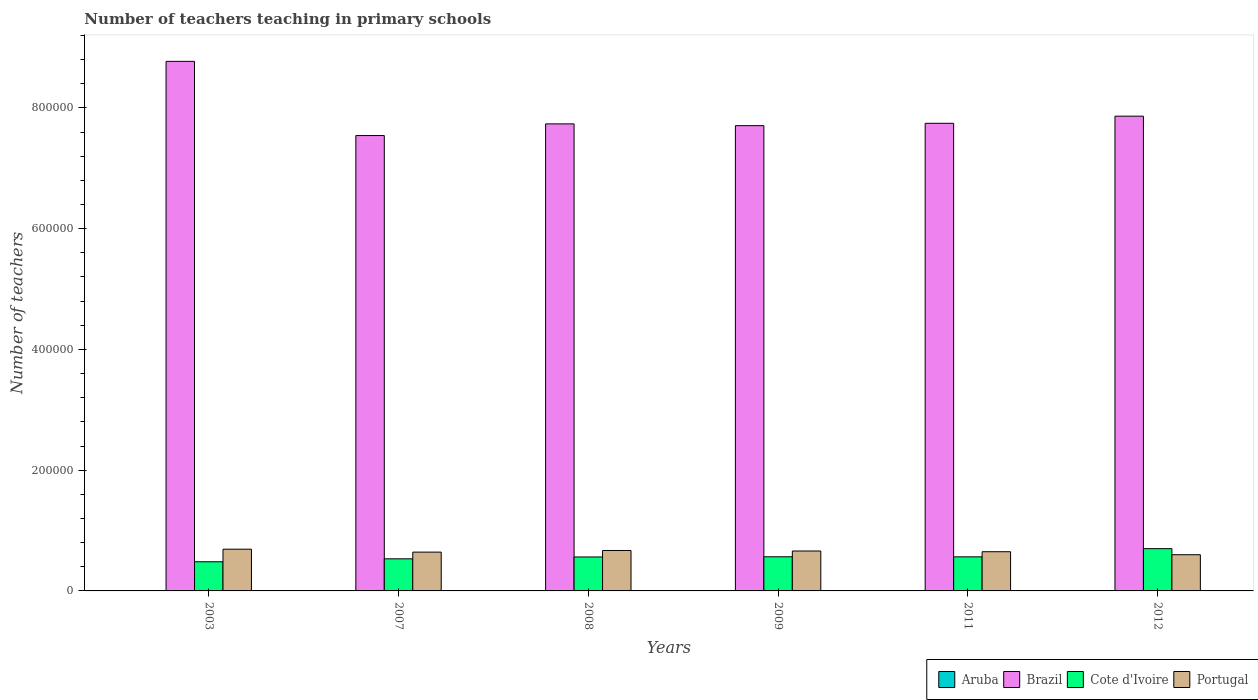How many different coloured bars are there?
Offer a very short reply. 4. How many groups of bars are there?
Your answer should be very brief. 6. Are the number of bars on each tick of the X-axis equal?
Give a very brief answer. Yes. How many bars are there on the 5th tick from the left?
Offer a very short reply. 4. How many bars are there on the 5th tick from the right?
Ensure brevity in your answer.  4. What is the label of the 1st group of bars from the left?
Ensure brevity in your answer.  2003. What is the number of teachers teaching in primary schools in Cote d'Ivoire in 2003?
Offer a terse response. 4.83e+04. Across all years, what is the maximum number of teachers teaching in primary schools in Portugal?
Your answer should be very brief. 6.91e+04. Across all years, what is the minimum number of teachers teaching in primary schools in Aruba?
Your response must be concise. 537. In which year was the number of teachers teaching in primary schools in Cote d'Ivoire maximum?
Your response must be concise. 2012. What is the total number of teachers teaching in primary schools in Aruba in the graph?
Provide a short and direct response. 3497. What is the difference between the number of teachers teaching in primary schools in Brazil in 2008 and that in 2012?
Provide a succinct answer. -1.28e+04. What is the difference between the number of teachers teaching in primary schools in Cote d'Ivoire in 2011 and the number of teachers teaching in primary schools in Aruba in 2009?
Ensure brevity in your answer.  5.59e+04. What is the average number of teachers teaching in primary schools in Aruba per year?
Provide a succinct answer. 582.83. In the year 2012, what is the difference between the number of teachers teaching in primary schools in Brazil and number of teachers teaching in primary schools in Portugal?
Ensure brevity in your answer.  7.26e+05. In how many years, is the number of teachers teaching in primary schools in Brazil greater than 520000?
Ensure brevity in your answer.  6. What is the ratio of the number of teachers teaching in primary schools in Brazil in 2003 to that in 2009?
Your answer should be compact. 1.14. What is the difference between the highest and the second highest number of teachers teaching in primary schools in Portugal?
Ensure brevity in your answer.  2153. What is the difference between the highest and the lowest number of teachers teaching in primary schools in Cote d'Ivoire?
Provide a succinct answer. 2.17e+04. In how many years, is the number of teachers teaching in primary schools in Brazil greater than the average number of teachers teaching in primary schools in Brazil taken over all years?
Provide a succinct answer. 1. What does the 3rd bar from the right in 2011 represents?
Your answer should be compact. Brazil. How many years are there in the graph?
Your response must be concise. 6. What is the difference between two consecutive major ticks on the Y-axis?
Make the answer very short. 2.00e+05. Are the values on the major ticks of Y-axis written in scientific E-notation?
Provide a succinct answer. No. Does the graph contain grids?
Offer a very short reply. No. What is the title of the graph?
Provide a short and direct response. Number of teachers teaching in primary schools. Does "Ukraine" appear as one of the legend labels in the graph?
Keep it short and to the point. No. What is the label or title of the Y-axis?
Your answer should be very brief. Number of teachers. What is the Number of teachers in Aruba in 2003?
Your response must be concise. 537. What is the Number of teachers in Brazil in 2003?
Ensure brevity in your answer.  8.77e+05. What is the Number of teachers in Cote d'Ivoire in 2003?
Ensure brevity in your answer.  4.83e+04. What is the Number of teachers of Portugal in 2003?
Your answer should be very brief. 6.91e+04. What is the Number of teachers in Aruba in 2007?
Your answer should be very brief. 594. What is the Number of teachers of Brazil in 2007?
Give a very brief answer. 7.54e+05. What is the Number of teachers in Cote d'Ivoire in 2007?
Provide a short and direct response. 5.32e+04. What is the Number of teachers in Portugal in 2007?
Your answer should be very brief. 6.43e+04. What is the Number of teachers of Aruba in 2008?
Give a very brief answer. 579. What is the Number of teachers in Brazil in 2008?
Ensure brevity in your answer.  7.74e+05. What is the Number of teachers of Cote d'Ivoire in 2008?
Offer a very short reply. 5.62e+04. What is the Number of teachers in Portugal in 2008?
Provide a short and direct response. 6.70e+04. What is the Number of teachers of Aruba in 2009?
Ensure brevity in your answer.  582. What is the Number of teachers of Brazil in 2009?
Offer a very short reply. 7.71e+05. What is the Number of teachers in Cote d'Ivoire in 2009?
Your answer should be compact. 5.66e+04. What is the Number of teachers of Portugal in 2009?
Offer a terse response. 6.61e+04. What is the Number of teachers in Aruba in 2011?
Make the answer very short. 604. What is the Number of teachers of Brazil in 2011?
Provide a succinct answer. 7.75e+05. What is the Number of teachers of Cote d'Ivoire in 2011?
Ensure brevity in your answer.  5.65e+04. What is the Number of teachers of Portugal in 2011?
Provide a succinct answer. 6.49e+04. What is the Number of teachers of Aruba in 2012?
Offer a very short reply. 601. What is the Number of teachers in Brazil in 2012?
Make the answer very short. 7.86e+05. What is the Number of teachers in Cote d'Ivoire in 2012?
Your answer should be compact. 7.00e+04. What is the Number of teachers of Portugal in 2012?
Offer a terse response. 6.00e+04. Across all years, what is the maximum Number of teachers in Aruba?
Make the answer very short. 604. Across all years, what is the maximum Number of teachers in Brazil?
Offer a terse response. 8.77e+05. Across all years, what is the maximum Number of teachers in Cote d'Ivoire?
Your response must be concise. 7.00e+04. Across all years, what is the maximum Number of teachers in Portugal?
Offer a very short reply. 6.91e+04. Across all years, what is the minimum Number of teachers in Aruba?
Give a very brief answer. 537. Across all years, what is the minimum Number of teachers in Brazil?
Provide a short and direct response. 7.54e+05. Across all years, what is the minimum Number of teachers in Cote d'Ivoire?
Offer a very short reply. 4.83e+04. Across all years, what is the minimum Number of teachers in Portugal?
Your answer should be very brief. 6.00e+04. What is the total Number of teachers in Aruba in the graph?
Give a very brief answer. 3497. What is the total Number of teachers in Brazil in the graph?
Your answer should be very brief. 4.74e+06. What is the total Number of teachers in Cote d'Ivoire in the graph?
Your answer should be very brief. 3.41e+05. What is the total Number of teachers of Portugal in the graph?
Provide a succinct answer. 3.91e+05. What is the difference between the Number of teachers of Aruba in 2003 and that in 2007?
Offer a very short reply. -57. What is the difference between the Number of teachers of Brazil in 2003 and that in 2007?
Give a very brief answer. 1.23e+05. What is the difference between the Number of teachers in Cote d'Ivoire in 2003 and that in 2007?
Make the answer very short. -4853. What is the difference between the Number of teachers of Portugal in 2003 and that in 2007?
Provide a succinct answer. 4835. What is the difference between the Number of teachers of Aruba in 2003 and that in 2008?
Ensure brevity in your answer.  -42. What is the difference between the Number of teachers of Brazil in 2003 and that in 2008?
Make the answer very short. 1.04e+05. What is the difference between the Number of teachers of Cote d'Ivoire in 2003 and that in 2008?
Give a very brief answer. -7940. What is the difference between the Number of teachers in Portugal in 2003 and that in 2008?
Make the answer very short. 2153. What is the difference between the Number of teachers of Aruba in 2003 and that in 2009?
Offer a very short reply. -45. What is the difference between the Number of teachers in Brazil in 2003 and that in 2009?
Your response must be concise. 1.07e+05. What is the difference between the Number of teachers in Cote d'Ivoire in 2003 and that in 2009?
Your answer should be compact. -8267. What is the difference between the Number of teachers of Portugal in 2003 and that in 2009?
Your response must be concise. 3003. What is the difference between the Number of teachers in Aruba in 2003 and that in 2011?
Your answer should be compact. -67. What is the difference between the Number of teachers in Brazil in 2003 and that in 2011?
Provide a succinct answer. 1.03e+05. What is the difference between the Number of teachers in Cote d'Ivoire in 2003 and that in 2011?
Make the answer very short. -8147. What is the difference between the Number of teachers in Portugal in 2003 and that in 2011?
Keep it short and to the point. 4180. What is the difference between the Number of teachers of Aruba in 2003 and that in 2012?
Provide a succinct answer. -64. What is the difference between the Number of teachers of Brazil in 2003 and that in 2012?
Provide a succinct answer. 9.08e+04. What is the difference between the Number of teachers in Cote d'Ivoire in 2003 and that in 2012?
Provide a succinct answer. -2.17e+04. What is the difference between the Number of teachers in Portugal in 2003 and that in 2012?
Your response must be concise. 9154. What is the difference between the Number of teachers of Aruba in 2007 and that in 2008?
Ensure brevity in your answer.  15. What is the difference between the Number of teachers in Brazil in 2007 and that in 2008?
Ensure brevity in your answer.  -1.93e+04. What is the difference between the Number of teachers in Cote d'Ivoire in 2007 and that in 2008?
Ensure brevity in your answer.  -3087. What is the difference between the Number of teachers in Portugal in 2007 and that in 2008?
Provide a succinct answer. -2682. What is the difference between the Number of teachers in Aruba in 2007 and that in 2009?
Your answer should be compact. 12. What is the difference between the Number of teachers of Brazil in 2007 and that in 2009?
Give a very brief answer. -1.64e+04. What is the difference between the Number of teachers in Cote d'Ivoire in 2007 and that in 2009?
Keep it short and to the point. -3414. What is the difference between the Number of teachers of Portugal in 2007 and that in 2009?
Offer a very short reply. -1832. What is the difference between the Number of teachers in Brazil in 2007 and that in 2011?
Provide a short and direct response. -2.03e+04. What is the difference between the Number of teachers in Cote d'Ivoire in 2007 and that in 2011?
Your answer should be very brief. -3294. What is the difference between the Number of teachers in Portugal in 2007 and that in 2011?
Offer a very short reply. -655. What is the difference between the Number of teachers in Brazil in 2007 and that in 2012?
Ensure brevity in your answer.  -3.21e+04. What is the difference between the Number of teachers of Cote d'Ivoire in 2007 and that in 2012?
Provide a short and direct response. -1.69e+04. What is the difference between the Number of teachers in Portugal in 2007 and that in 2012?
Your answer should be very brief. 4319. What is the difference between the Number of teachers of Brazil in 2008 and that in 2009?
Provide a succinct answer. 2921. What is the difference between the Number of teachers in Cote d'Ivoire in 2008 and that in 2009?
Ensure brevity in your answer.  -327. What is the difference between the Number of teachers of Portugal in 2008 and that in 2009?
Keep it short and to the point. 850. What is the difference between the Number of teachers in Brazil in 2008 and that in 2011?
Offer a terse response. -951. What is the difference between the Number of teachers of Cote d'Ivoire in 2008 and that in 2011?
Your response must be concise. -207. What is the difference between the Number of teachers in Portugal in 2008 and that in 2011?
Make the answer very short. 2027. What is the difference between the Number of teachers of Aruba in 2008 and that in 2012?
Your answer should be compact. -22. What is the difference between the Number of teachers in Brazil in 2008 and that in 2012?
Provide a succinct answer. -1.28e+04. What is the difference between the Number of teachers of Cote d'Ivoire in 2008 and that in 2012?
Your response must be concise. -1.38e+04. What is the difference between the Number of teachers of Portugal in 2008 and that in 2012?
Your answer should be very brief. 7001. What is the difference between the Number of teachers in Aruba in 2009 and that in 2011?
Provide a succinct answer. -22. What is the difference between the Number of teachers of Brazil in 2009 and that in 2011?
Provide a short and direct response. -3872. What is the difference between the Number of teachers in Cote d'Ivoire in 2009 and that in 2011?
Provide a succinct answer. 120. What is the difference between the Number of teachers in Portugal in 2009 and that in 2011?
Your answer should be compact. 1177. What is the difference between the Number of teachers in Brazil in 2009 and that in 2012?
Give a very brief answer. -1.57e+04. What is the difference between the Number of teachers in Cote d'Ivoire in 2009 and that in 2012?
Your answer should be very brief. -1.34e+04. What is the difference between the Number of teachers in Portugal in 2009 and that in 2012?
Provide a succinct answer. 6151. What is the difference between the Number of teachers in Brazil in 2011 and that in 2012?
Offer a terse response. -1.18e+04. What is the difference between the Number of teachers in Cote d'Ivoire in 2011 and that in 2012?
Provide a short and direct response. -1.36e+04. What is the difference between the Number of teachers in Portugal in 2011 and that in 2012?
Provide a short and direct response. 4974. What is the difference between the Number of teachers of Aruba in 2003 and the Number of teachers of Brazil in 2007?
Offer a terse response. -7.54e+05. What is the difference between the Number of teachers in Aruba in 2003 and the Number of teachers in Cote d'Ivoire in 2007?
Your response must be concise. -5.26e+04. What is the difference between the Number of teachers of Aruba in 2003 and the Number of teachers of Portugal in 2007?
Provide a succinct answer. -6.37e+04. What is the difference between the Number of teachers in Brazil in 2003 and the Number of teachers in Cote d'Ivoire in 2007?
Your answer should be very brief. 8.24e+05. What is the difference between the Number of teachers in Brazil in 2003 and the Number of teachers in Portugal in 2007?
Keep it short and to the point. 8.13e+05. What is the difference between the Number of teachers of Cote d'Ivoire in 2003 and the Number of teachers of Portugal in 2007?
Make the answer very short. -1.60e+04. What is the difference between the Number of teachers in Aruba in 2003 and the Number of teachers in Brazil in 2008?
Keep it short and to the point. -7.73e+05. What is the difference between the Number of teachers of Aruba in 2003 and the Number of teachers of Cote d'Ivoire in 2008?
Your answer should be compact. -5.57e+04. What is the difference between the Number of teachers of Aruba in 2003 and the Number of teachers of Portugal in 2008?
Make the answer very short. -6.64e+04. What is the difference between the Number of teachers of Brazil in 2003 and the Number of teachers of Cote d'Ivoire in 2008?
Keep it short and to the point. 8.21e+05. What is the difference between the Number of teachers of Brazil in 2003 and the Number of teachers of Portugal in 2008?
Provide a succinct answer. 8.10e+05. What is the difference between the Number of teachers in Cote d'Ivoire in 2003 and the Number of teachers in Portugal in 2008?
Provide a succinct answer. -1.86e+04. What is the difference between the Number of teachers of Aruba in 2003 and the Number of teachers of Brazil in 2009?
Your response must be concise. -7.70e+05. What is the difference between the Number of teachers in Aruba in 2003 and the Number of teachers in Cote d'Ivoire in 2009?
Offer a terse response. -5.60e+04. What is the difference between the Number of teachers in Aruba in 2003 and the Number of teachers in Portugal in 2009?
Make the answer very short. -6.56e+04. What is the difference between the Number of teachers in Brazil in 2003 and the Number of teachers in Cote d'Ivoire in 2009?
Your answer should be compact. 8.21e+05. What is the difference between the Number of teachers in Brazil in 2003 and the Number of teachers in Portugal in 2009?
Offer a very short reply. 8.11e+05. What is the difference between the Number of teachers of Cote d'Ivoire in 2003 and the Number of teachers of Portugal in 2009?
Your response must be concise. -1.78e+04. What is the difference between the Number of teachers in Aruba in 2003 and the Number of teachers in Brazil in 2011?
Your response must be concise. -7.74e+05. What is the difference between the Number of teachers of Aruba in 2003 and the Number of teachers of Cote d'Ivoire in 2011?
Your answer should be compact. -5.59e+04. What is the difference between the Number of teachers in Aruba in 2003 and the Number of teachers in Portugal in 2011?
Provide a short and direct response. -6.44e+04. What is the difference between the Number of teachers in Brazil in 2003 and the Number of teachers in Cote d'Ivoire in 2011?
Your answer should be compact. 8.21e+05. What is the difference between the Number of teachers in Brazil in 2003 and the Number of teachers in Portugal in 2011?
Ensure brevity in your answer.  8.12e+05. What is the difference between the Number of teachers in Cote d'Ivoire in 2003 and the Number of teachers in Portugal in 2011?
Ensure brevity in your answer.  -1.66e+04. What is the difference between the Number of teachers in Aruba in 2003 and the Number of teachers in Brazil in 2012?
Your answer should be very brief. -7.86e+05. What is the difference between the Number of teachers of Aruba in 2003 and the Number of teachers of Cote d'Ivoire in 2012?
Keep it short and to the point. -6.95e+04. What is the difference between the Number of teachers of Aruba in 2003 and the Number of teachers of Portugal in 2012?
Provide a short and direct response. -5.94e+04. What is the difference between the Number of teachers of Brazil in 2003 and the Number of teachers of Cote d'Ivoire in 2012?
Your answer should be compact. 8.07e+05. What is the difference between the Number of teachers of Brazil in 2003 and the Number of teachers of Portugal in 2012?
Your answer should be very brief. 8.17e+05. What is the difference between the Number of teachers in Cote d'Ivoire in 2003 and the Number of teachers in Portugal in 2012?
Make the answer very short. -1.16e+04. What is the difference between the Number of teachers in Aruba in 2007 and the Number of teachers in Brazil in 2008?
Your response must be concise. -7.73e+05. What is the difference between the Number of teachers of Aruba in 2007 and the Number of teachers of Cote d'Ivoire in 2008?
Keep it short and to the point. -5.57e+04. What is the difference between the Number of teachers of Aruba in 2007 and the Number of teachers of Portugal in 2008?
Ensure brevity in your answer.  -6.64e+04. What is the difference between the Number of teachers of Brazil in 2007 and the Number of teachers of Cote d'Ivoire in 2008?
Offer a terse response. 6.98e+05. What is the difference between the Number of teachers in Brazil in 2007 and the Number of teachers in Portugal in 2008?
Offer a terse response. 6.87e+05. What is the difference between the Number of teachers of Cote d'Ivoire in 2007 and the Number of teachers of Portugal in 2008?
Offer a terse response. -1.38e+04. What is the difference between the Number of teachers of Aruba in 2007 and the Number of teachers of Brazil in 2009?
Offer a terse response. -7.70e+05. What is the difference between the Number of teachers of Aruba in 2007 and the Number of teachers of Cote d'Ivoire in 2009?
Offer a very short reply. -5.60e+04. What is the difference between the Number of teachers in Aruba in 2007 and the Number of teachers in Portugal in 2009?
Offer a terse response. -6.55e+04. What is the difference between the Number of teachers in Brazil in 2007 and the Number of teachers in Cote d'Ivoire in 2009?
Keep it short and to the point. 6.98e+05. What is the difference between the Number of teachers of Brazil in 2007 and the Number of teachers of Portugal in 2009?
Provide a short and direct response. 6.88e+05. What is the difference between the Number of teachers of Cote d'Ivoire in 2007 and the Number of teachers of Portugal in 2009?
Make the answer very short. -1.29e+04. What is the difference between the Number of teachers in Aruba in 2007 and the Number of teachers in Brazil in 2011?
Make the answer very short. -7.74e+05. What is the difference between the Number of teachers in Aruba in 2007 and the Number of teachers in Cote d'Ivoire in 2011?
Make the answer very short. -5.59e+04. What is the difference between the Number of teachers in Aruba in 2007 and the Number of teachers in Portugal in 2011?
Provide a short and direct response. -6.43e+04. What is the difference between the Number of teachers of Brazil in 2007 and the Number of teachers of Cote d'Ivoire in 2011?
Provide a succinct answer. 6.98e+05. What is the difference between the Number of teachers of Brazil in 2007 and the Number of teachers of Portugal in 2011?
Make the answer very short. 6.89e+05. What is the difference between the Number of teachers of Cote d'Ivoire in 2007 and the Number of teachers of Portugal in 2011?
Provide a short and direct response. -1.18e+04. What is the difference between the Number of teachers in Aruba in 2007 and the Number of teachers in Brazil in 2012?
Keep it short and to the point. -7.86e+05. What is the difference between the Number of teachers of Aruba in 2007 and the Number of teachers of Cote d'Ivoire in 2012?
Your answer should be compact. -6.94e+04. What is the difference between the Number of teachers in Aruba in 2007 and the Number of teachers in Portugal in 2012?
Your answer should be compact. -5.94e+04. What is the difference between the Number of teachers in Brazil in 2007 and the Number of teachers in Cote d'Ivoire in 2012?
Give a very brief answer. 6.84e+05. What is the difference between the Number of teachers in Brazil in 2007 and the Number of teachers in Portugal in 2012?
Provide a succinct answer. 6.94e+05. What is the difference between the Number of teachers in Cote d'Ivoire in 2007 and the Number of teachers in Portugal in 2012?
Offer a terse response. -6794. What is the difference between the Number of teachers in Aruba in 2008 and the Number of teachers in Brazil in 2009?
Offer a terse response. -7.70e+05. What is the difference between the Number of teachers in Aruba in 2008 and the Number of teachers in Cote d'Ivoire in 2009?
Provide a short and direct response. -5.60e+04. What is the difference between the Number of teachers in Aruba in 2008 and the Number of teachers in Portugal in 2009?
Give a very brief answer. -6.55e+04. What is the difference between the Number of teachers in Brazil in 2008 and the Number of teachers in Cote d'Ivoire in 2009?
Keep it short and to the point. 7.17e+05. What is the difference between the Number of teachers in Brazil in 2008 and the Number of teachers in Portugal in 2009?
Keep it short and to the point. 7.08e+05. What is the difference between the Number of teachers of Cote d'Ivoire in 2008 and the Number of teachers of Portugal in 2009?
Offer a very short reply. -9858. What is the difference between the Number of teachers of Aruba in 2008 and the Number of teachers of Brazil in 2011?
Your answer should be compact. -7.74e+05. What is the difference between the Number of teachers of Aruba in 2008 and the Number of teachers of Cote d'Ivoire in 2011?
Your answer should be very brief. -5.59e+04. What is the difference between the Number of teachers of Aruba in 2008 and the Number of teachers of Portugal in 2011?
Offer a very short reply. -6.44e+04. What is the difference between the Number of teachers of Brazil in 2008 and the Number of teachers of Cote d'Ivoire in 2011?
Make the answer very short. 7.17e+05. What is the difference between the Number of teachers in Brazil in 2008 and the Number of teachers in Portugal in 2011?
Ensure brevity in your answer.  7.09e+05. What is the difference between the Number of teachers in Cote d'Ivoire in 2008 and the Number of teachers in Portugal in 2011?
Offer a very short reply. -8681. What is the difference between the Number of teachers in Aruba in 2008 and the Number of teachers in Brazil in 2012?
Provide a short and direct response. -7.86e+05. What is the difference between the Number of teachers of Aruba in 2008 and the Number of teachers of Cote d'Ivoire in 2012?
Your response must be concise. -6.94e+04. What is the difference between the Number of teachers of Aruba in 2008 and the Number of teachers of Portugal in 2012?
Provide a succinct answer. -5.94e+04. What is the difference between the Number of teachers of Brazil in 2008 and the Number of teachers of Cote d'Ivoire in 2012?
Provide a succinct answer. 7.04e+05. What is the difference between the Number of teachers of Brazil in 2008 and the Number of teachers of Portugal in 2012?
Your answer should be very brief. 7.14e+05. What is the difference between the Number of teachers of Cote d'Ivoire in 2008 and the Number of teachers of Portugal in 2012?
Your answer should be compact. -3707. What is the difference between the Number of teachers of Aruba in 2009 and the Number of teachers of Brazil in 2011?
Keep it short and to the point. -7.74e+05. What is the difference between the Number of teachers of Aruba in 2009 and the Number of teachers of Cote d'Ivoire in 2011?
Provide a short and direct response. -5.59e+04. What is the difference between the Number of teachers of Aruba in 2009 and the Number of teachers of Portugal in 2011?
Provide a succinct answer. -6.43e+04. What is the difference between the Number of teachers of Brazil in 2009 and the Number of teachers of Cote d'Ivoire in 2011?
Make the answer very short. 7.14e+05. What is the difference between the Number of teachers of Brazil in 2009 and the Number of teachers of Portugal in 2011?
Make the answer very short. 7.06e+05. What is the difference between the Number of teachers in Cote d'Ivoire in 2009 and the Number of teachers in Portugal in 2011?
Give a very brief answer. -8354. What is the difference between the Number of teachers of Aruba in 2009 and the Number of teachers of Brazil in 2012?
Your response must be concise. -7.86e+05. What is the difference between the Number of teachers of Aruba in 2009 and the Number of teachers of Cote d'Ivoire in 2012?
Ensure brevity in your answer.  -6.94e+04. What is the difference between the Number of teachers in Aruba in 2009 and the Number of teachers in Portugal in 2012?
Offer a very short reply. -5.94e+04. What is the difference between the Number of teachers of Brazil in 2009 and the Number of teachers of Cote d'Ivoire in 2012?
Make the answer very short. 7.01e+05. What is the difference between the Number of teachers of Brazil in 2009 and the Number of teachers of Portugal in 2012?
Offer a terse response. 7.11e+05. What is the difference between the Number of teachers of Cote d'Ivoire in 2009 and the Number of teachers of Portugal in 2012?
Keep it short and to the point. -3380. What is the difference between the Number of teachers in Aruba in 2011 and the Number of teachers in Brazil in 2012?
Your response must be concise. -7.86e+05. What is the difference between the Number of teachers in Aruba in 2011 and the Number of teachers in Cote d'Ivoire in 2012?
Your answer should be compact. -6.94e+04. What is the difference between the Number of teachers in Aruba in 2011 and the Number of teachers in Portugal in 2012?
Your answer should be very brief. -5.94e+04. What is the difference between the Number of teachers of Brazil in 2011 and the Number of teachers of Cote d'Ivoire in 2012?
Offer a terse response. 7.05e+05. What is the difference between the Number of teachers in Brazil in 2011 and the Number of teachers in Portugal in 2012?
Your answer should be very brief. 7.15e+05. What is the difference between the Number of teachers in Cote d'Ivoire in 2011 and the Number of teachers in Portugal in 2012?
Provide a succinct answer. -3500. What is the average Number of teachers of Aruba per year?
Your answer should be very brief. 582.83. What is the average Number of teachers in Brazil per year?
Offer a terse response. 7.89e+05. What is the average Number of teachers in Cote d'Ivoire per year?
Your answer should be compact. 5.68e+04. What is the average Number of teachers of Portugal per year?
Give a very brief answer. 6.52e+04. In the year 2003, what is the difference between the Number of teachers of Aruba and Number of teachers of Brazil?
Provide a succinct answer. -8.77e+05. In the year 2003, what is the difference between the Number of teachers of Aruba and Number of teachers of Cote d'Ivoire?
Provide a short and direct response. -4.78e+04. In the year 2003, what is the difference between the Number of teachers in Aruba and Number of teachers in Portugal?
Your answer should be compact. -6.86e+04. In the year 2003, what is the difference between the Number of teachers of Brazil and Number of teachers of Cote d'Ivoire?
Offer a terse response. 8.29e+05. In the year 2003, what is the difference between the Number of teachers of Brazil and Number of teachers of Portugal?
Provide a short and direct response. 8.08e+05. In the year 2003, what is the difference between the Number of teachers in Cote d'Ivoire and Number of teachers in Portugal?
Your answer should be very brief. -2.08e+04. In the year 2007, what is the difference between the Number of teachers of Aruba and Number of teachers of Brazil?
Offer a terse response. -7.54e+05. In the year 2007, what is the difference between the Number of teachers of Aruba and Number of teachers of Cote d'Ivoire?
Give a very brief answer. -5.26e+04. In the year 2007, what is the difference between the Number of teachers of Aruba and Number of teachers of Portugal?
Give a very brief answer. -6.37e+04. In the year 2007, what is the difference between the Number of teachers in Brazil and Number of teachers in Cote d'Ivoire?
Give a very brief answer. 7.01e+05. In the year 2007, what is the difference between the Number of teachers in Brazil and Number of teachers in Portugal?
Make the answer very short. 6.90e+05. In the year 2007, what is the difference between the Number of teachers in Cote d'Ivoire and Number of teachers in Portugal?
Your answer should be compact. -1.11e+04. In the year 2008, what is the difference between the Number of teachers of Aruba and Number of teachers of Brazil?
Keep it short and to the point. -7.73e+05. In the year 2008, what is the difference between the Number of teachers of Aruba and Number of teachers of Cote d'Ivoire?
Your answer should be compact. -5.57e+04. In the year 2008, what is the difference between the Number of teachers of Aruba and Number of teachers of Portugal?
Your response must be concise. -6.64e+04. In the year 2008, what is the difference between the Number of teachers in Brazil and Number of teachers in Cote d'Ivoire?
Keep it short and to the point. 7.17e+05. In the year 2008, what is the difference between the Number of teachers in Brazil and Number of teachers in Portugal?
Offer a very short reply. 7.07e+05. In the year 2008, what is the difference between the Number of teachers of Cote d'Ivoire and Number of teachers of Portugal?
Your response must be concise. -1.07e+04. In the year 2009, what is the difference between the Number of teachers of Aruba and Number of teachers of Brazil?
Your answer should be very brief. -7.70e+05. In the year 2009, what is the difference between the Number of teachers in Aruba and Number of teachers in Cote d'Ivoire?
Ensure brevity in your answer.  -5.60e+04. In the year 2009, what is the difference between the Number of teachers of Aruba and Number of teachers of Portugal?
Offer a terse response. -6.55e+04. In the year 2009, what is the difference between the Number of teachers in Brazil and Number of teachers in Cote d'Ivoire?
Your answer should be compact. 7.14e+05. In the year 2009, what is the difference between the Number of teachers in Brazil and Number of teachers in Portugal?
Give a very brief answer. 7.05e+05. In the year 2009, what is the difference between the Number of teachers of Cote d'Ivoire and Number of teachers of Portugal?
Ensure brevity in your answer.  -9531. In the year 2011, what is the difference between the Number of teachers of Aruba and Number of teachers of Brazil?
Offer a very short reply. -7.74e+05. In the year 2011, what is the difference between the Number of teachers of Aruba and Number of teachers of Cote d'Ivoire?
Give a very brief answer. -5.59e+04. In the year 2011, what is the difference between the Number of teachers in Aruba and Number of teachers in Portugal?
Make the answer very short. -6.43e+04. In the year 2011, what is the difference between the Number of teachers in Brazil and Number of teachers in Cote d'Ivoire?
Offer a terse response. 7.18e+05. In the year 2011, what is the difference between the Number of teachers of Brazil and Number of teachers of Portugal?
Your answer should be very brief. 7.10e+05. In the year 2011, what is the difference between the Number of teachers of Cote d'Ivoire and Number of teachers of Portugal?
Give a very brief answer. -8474. In the year 2012, what is the difference between the Number of teachers of Aruba and Number of teachers of Brazil?
Ensure brevity in your answer.  -7.86e+05. In the year 2012, what is the difference between the Number of teachers in Aruba and Number of teachers in Cote d'Ivoire?
Keep it short and to the point. -6.94e+04. In the year 2012, what is the difference between the Number of teachers in Aruba and Number of teachers in Portugal?
Your answer should be very brief. -5.94e+04. In the year 2012, what is the difference between the Number of teachers in Brazil and Number of teachers in Cote d'Ivoire?
Provide a short and direct response. 7.16e+05. In the year 2012, what is the difference between the Number of teachers in Brazil and Number of teachers in Portugal?
Your response must be concise. 7.26e+05. In the year 2012, what is the difference between the Number of teachers of Cote d'Ivoire and Number of teachers of Portugal?
Ensure brevity in your answer.  1.01e+04. What is the ratio of the Number of teachers of Aruba in 2003 to that in 2007?
Offer a terse response. 0.9. What is the ratio of the Number of teachers of Brazil in 2003 to that in 2007?
Offer a very short reply. 1.16. What is the ratio of the Number of teachers in Cote d'Ivoire in 2003 to that in 2007?
Make the answer very short. 0.91. What is the ratio of the Number of teachers in Portugal in 2003 to that in 2007?
Give a very brief answer. 1.08. What is the ratio of the Number of teachers in Aruba in 2003 to that in 2008?
Ensure brevity in your answer.  0.93. What is the ratio of the Number of teachers of Brazil in 2003 to that in 2008?
Your answer should be compact. 1.13. What is the ratio of the Number of teachers of Cote d'Ivoire in 2003 to that in 2008?
Offer a very short reply. 0.86. What is the ratio of the Number of teachers of Portugal in 2003 to that in 2008?
Your answer should be very brief. 1.03. What is the ratio of the Number of teachers of Aruba in 2003 to that in 2009?
Your answer should be compact. 0.92. What is the ratio of the Number of teachers in Brazil in 2003 to that in 2009?
Offer a very short reply. 1.14. What is the ratio of the Number of teachers in Cote d'Ivoire in 2003 to that in 2009?
Keep it short and to the point. 0.85. What is the ratio of the Number of teachers of Portugal in 2003 to that in 2009?
Make the answer very short. 1.05. What is the ratio of the Number of teachers of Aruba in 2003 to that in 2011?
Make the answer very short. 0.89. What is the ratio of the Number of teachers in Brazil in 2003 to that in 2011?
Your response must be concise. 1.13. What is the ratio of the Number of teachers in Cote d'Ivoire in 2003 to that in 2011?
Your answer should be very brief. 0.86. What is the ratio of the Number of teachers of Portugal in 2003 to that in 2011?
Your answer should be compact. 1.06. What is the ratio of the Number of teachers of Aruba in 2003 to that in 2012?
Your answer should be very brief. 0.89. What is the ratio of the Number of teachers in Brazil in 2003 to that in 2012?
Provide a short and direct response. 1.12. What is the ratio of the Number of teachers of Cote d'Ivoire in 2003 to that in 2012?
Your response must be concise. 0.69. What is the ratio of the Number of teachers in Portugal in 2003 to that in 2012?
Make the answer very short. 1.15. What is the ratio of the Number of teachers in Aruba in 2007 to that in 2008?
Keep it short and to the point. 1.03. What is the ratio of the Number of teachers of Brazil in 2007 to that in 2008?
Your response must be concise. 0.97. What is the ratio of the Number of teachers of Cote d'Ivoire in 2007 to that in 2008?
Your response must be concise. 0.95. What is the ratio of the Number of teachers in Portugal in 2007 to that in 2008?
Give a very brief answer. 0.96. What is the ratio of the Number of teachers in Aruba in 2007 to that in 2009?
Your answer should be very brief. 1.02. What is the ratio of the Number of teachers of Brazil in 2007 to that in 2009?
Ensure brevity in your answer.  0.98. What is the ratio of the Number of teachers in Cote d'Ivoire in 2007 to that in 2009?
Your response must be concise. 0.94. What is the ratio of the Number of teachers of Portugal in 2007 to that in 2009?
Your answer should be very brief. 0.97. What is the ratio of the Number of teachers of Aruba in 2007 to that in 2011?
Your answer should be compact. 0.98. What is the ratio of the Number of teachers in Brazil in 2007 to that in 2011?
Make the answer very short. 0.97. What is the ratio of the Number of teachers in Cote d'Ivoire in 2007 to that in 2011?
Offer a terse response. 0.94. What is the ratio of the Number of teachers of Aruba in 2007 to that in 2012?
Give a very brief answer. 0.99. What is the ratio of the Number of teachers in Brazil in 2007 to that in 2012?
Your response must be concise. 0.96. What is the ratio of the Number of teachers in Cote d'Ivoire in 2007 to that in 2012?
Offer a terse response. 0.76. What is the ratio of the Number of teachers in Portugal in 2007 to that in 2012?
Your answer should be compact. 1.07. What is the ratio of the Number of teachers of Aruba in 2008 to that in 2009?
Offer a very short reply. 0.99. What is the ratio of the Number of teachers in Portugal in 2008 to that in 2009?
Offer a terse response. 1.01. What is the ratio of the Number of teachers in Aruba in 2008 to that in 2011?
Offer a very short reply. 0.96. What is the ratio of the Number of teachers in Brazil in 2008 to that in 2011?
Your answer should be compact. 1. What is the ratio of the Number of teachers in Cote d'Ivoire in 2008 to that in 2011?
Make the answer very short. 1. What is the ratio of the Number of teachers of Portugal in 2008 to that in 2011?
Keep it short and to the point. 1.03. What is the ratio of the Number of teachers in Aruba in 2008 to that in 2012?
Offer a very short reply. 0.96. What is the ratio of the Number of teachers of Brazil in 2008 to that in 2012?
Offer a terse response. 0.98. What is the ratio of the Number of teachers of Cote d'Ivoire in 2008 to that in 2012?
Your response must be concise. 0.8. What is the ratio of the Number of teachers in Portugal in 2008 to that in 2012?
Offer a very short reply. 1.12. What is the ratio of the Number of teachers of Aruba in 2009 to that in 2011?
Your answer should be compact. 0.96. What is the ratio of the Number of teachers of Cote d'Ivoire in 2009 to that in 2011?
Make the answer very short. 1. What is the ratio of the Number of teachers in Portugal in 2009 to that in 2011?
Ensure brevity in your answer.  1.02. What is the ratio of the Number of teachers in Aruba in 2009 to that in 2012?
Make the answer very short. 0.97. What is the ratio of the Number of teachers in Brazil in 2009 to that in 2012?
Ensure brevity in your answer.  0.98. What is the ratio of the Number of teachers in Cote d'Ivoire in 2009 to that in 2012?
Provide a succinct answer. 0.81. What is the ratio of the Number of teachers in Portugal in 2009 to that in 2012?
Ensure brevity in your answer.  1.1. What is the ratio of the Number of teachers in Brazil in 2011 to that in 2012?
Your answer should be very brief. 0.98. What is the ratio of the Number of teachers in Cote d'Ivoire in 2011 to that in 2012?
Give a very brief answer. 0.81. What is the ratio of the Number of teachers of Portugal in 2011 to that in 2012?
Offer a terse response. 1.08. What is the difference between the highest and the second highest Number of teachers in Aruba?
Keep it short and to the point. 3. What is the difference between the highest and the second highest Number of teachers of Brazil?
Give a very brief answer. 9.08e+04. What is the difference between the highest and the second highest Number of teachers of Cote d'Ivoire?
Make the answer very short. 1.34e+04. What is the difference between the highest and the second highest Number of teachers of Portugal?
Offer a terse response. 2153. What is the difference between the highest and the lowest Number of teachers of Brazil?
Offer a terse response. 1.23e+05. What is the difference between the highest and the lowest Number of teachers in Cote d'Ivoire?
Make the answer very short. 2.17e+04. What is the difference between the highest and the lowest Number of teachers in Portugal?
Ensure brevity in your answer.  9154. 